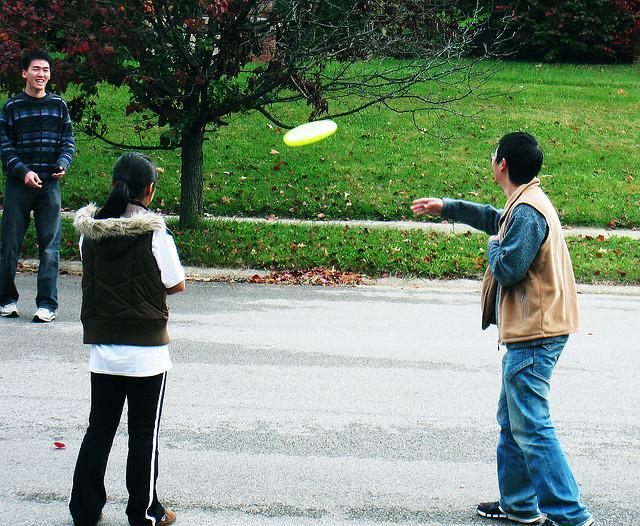Where does one buy a frisbee?
Be succinct. Store. Is someone wearing a hat?
Answer briefly. No. Will the man in the brown vest have to jump to catch this frisbee?
Concise answer only. No. 